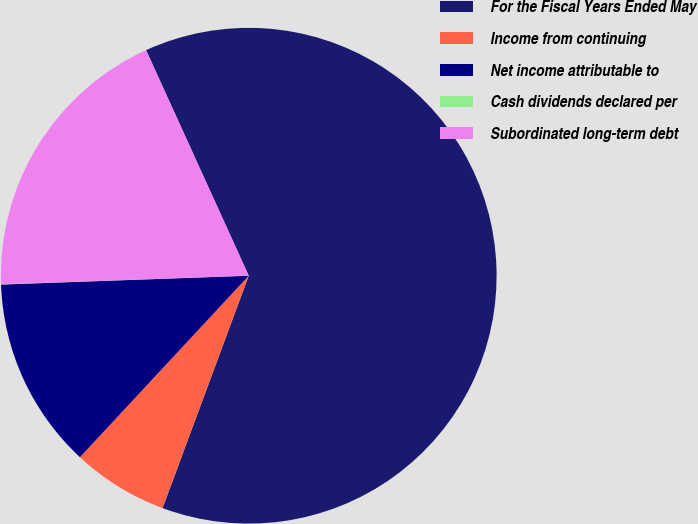<chart> <loc_0><loc_0><loc_500><loc_500><pie_chart><fcel>For the Fiscal Years Ended May<fcel>Income from continuing<fcel>Net income attributable to<fcel>Cash dividends declared per<fcel>Subordinated long-term debt<nl><fcel>62.45%<fcel>6.27%<fcel>12.51%<fcel>0.02%<fcel>18.75%<nl></chart> 